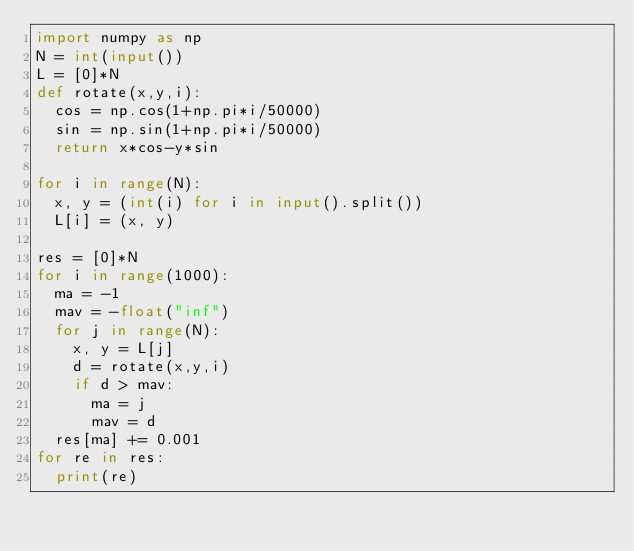Convert code to text. <code><loc_0><loc_0><loc_500><loc_500><_Python_>import numpy as np
N = int(input())
L = [0]*N
def rotate(x,y,i):
  cos = np.cos(1+np.pi*i/50000)
  sin = np.sin(1+np.pi*i/50000)
  return x*cos-y*sin

for i in range(N):
  x, y = (int(i) for i in input().split())
  L[i] = (x, y)

res = [0]*N
for i in range(1000):
  ma = -1
  mav = -float("inf")
  for j in range(N):
    x, y = L[j]
    d = rotate(x,y,i)
    if d > mav:
      ma = j
      mav = d
  res[ma] += 0.001
for re in res:
  print(re)</code> 